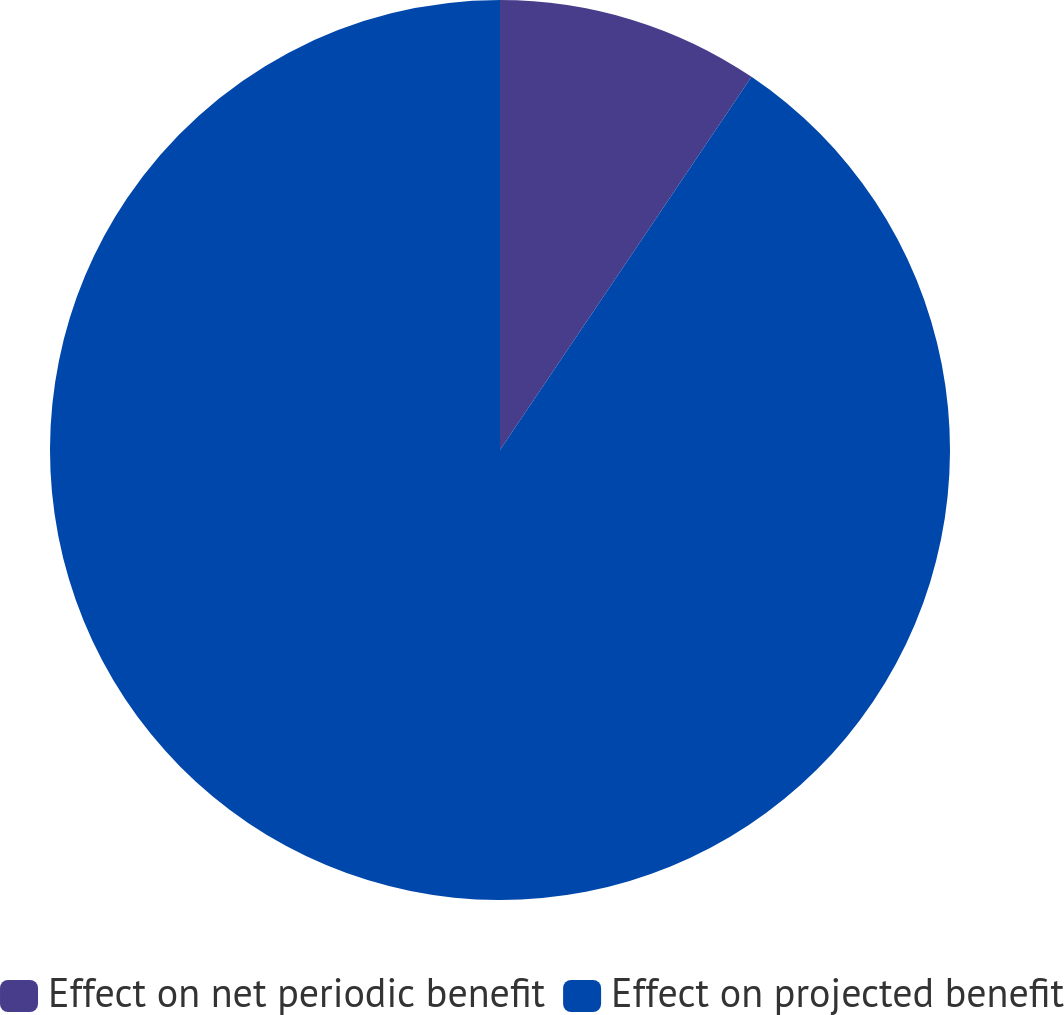Convert chart. <chart><loc_0><loc_0><loc_500><loc_500><pie_chart><fcel>Effect on net periodic benefit<fcel>Effect on projected benefit<nl><fcel>9.44%<fcel>90.56%<nl></chart> 